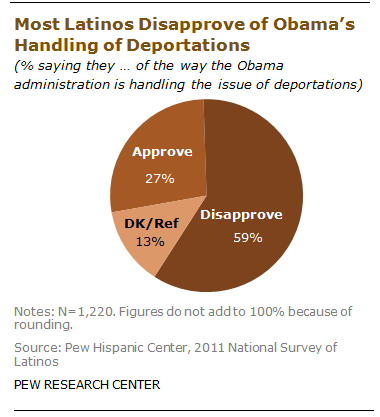Mention a couple of crucial points in this snapshot. Barack Obama is the leader who is analyzed in the chart. 